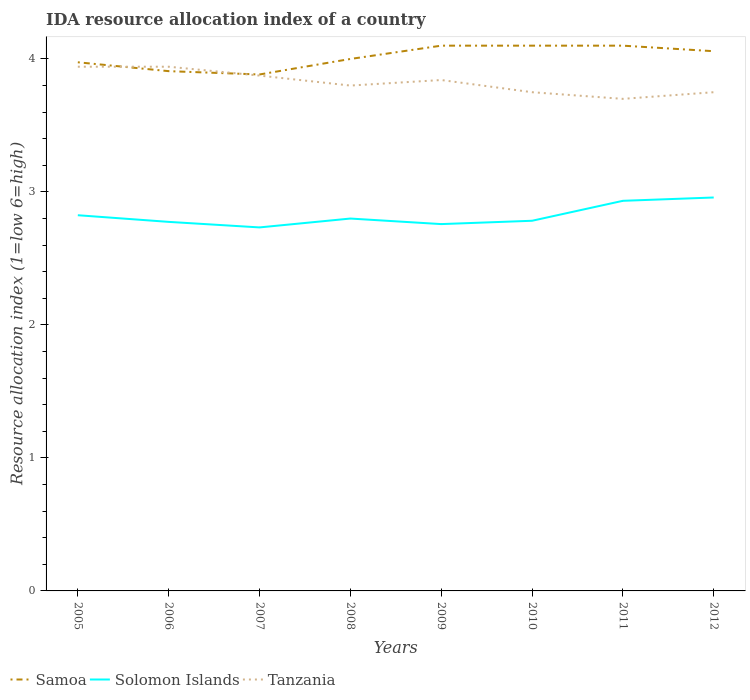How many different coloured lines are there?
Your response must be concise. 3. Does the line corresponding to Solomon Islands intersect with the line corresponding to Tanzania?
Provide a short and direct response. No. Across all years, what is the maximum IDA resource allocation index in Samoa?
Offer a terse response. 3.88. In which year was the IDA resource allocation index in Tanzania maximum?
Ensure brevity in your answer.  2011. What is the total IDA resource allocation index in Samoa in the graph?
Ensure brevity in your answer.  -0.12. What is the difference between the highest and the second highest IDA resource allocation index in Samoa?
Your answer should be very brief. 0.22. Does the graph contain any zero values?
Your response must be concise. No. Does the graph contain grids?
Provide a succinct answer. No. Where does the legend appear in the graph?
Keep it short and to the point. Bottom left. How many legend labels are there?
Keep it short and to the point. 3. How are the legend labels stacked?
Provide a succinct answer. Horizontal. What is the title of the graph?
Provide a short and direct response. IDA resource allocation index of a country. What is the label or title of the X-axis?
Give a very brief answer. Years. What is the label or title of the Y-axis?
Your answer should be compact. Resource allocation index (1=low 6=high). What is the Resource allocation index (1=low 6=high) in Samoa in 2005?
Your answer should be compact. 3.98. What is the Resource allocation index (1=low 6=high) in Solomon Islands in 2005?
Offer a terse response. 2.83. What is the Resource allocation index (1=low 6=high) of Tanzania in 2005?
Keep it short and to the point. 3.94. What is the Resource allocation index (1=low 6=high) of Samoa in 2006?
Keep it short and to the point. 3.91. What is the Resource allocation index (1=low 6=high) of Solomon Islands in 2006?
Provide a short and direct response. 2.77. What is the Resource allocation index (1=low 6=high) of Tanzania in 2006?
Your response must be concise. 3.94. What is the Resource allocation index (1=low 6=high) of Samoa in 2007?
Keep it short and to the point. 3.88. What is the Resource allocation index (1=low 6=high) in Solomon Islands in 2007?
Ensure brevity in your answer.  2.73. What is the Resource allocation index (1=low 6=high) in Tanzania in 2007?
Provide a short and direct response. 3.88. What is the Resource allocation index (1=low 6=high) of Samoa in 2008?
Keep it short and to the point. 4. What is the Resource allocation index (1=low 6=high) of Solomon Islands in 2008?
Provide a succinct answer. 2.8. What is the Resource allocation index (1=low 6=high) of Samoa in 2009?
Give a very brief answer. 4.1. What is the Resource allocation index (1=low 6=high) in Solomon Islands in 2009?
Your answer should be very brief. 2.76. What is the Resource allocation index (1=low 6=high) of Tanzania in 2009?
Your answer should be very brief. 3.84. What is the Resource allocation index (1=low 6=high) of Samoa in 2010?
Give a very brief answer. 4.1. What is the Resource allocation index (1=low 6=high) in Solomon Islands in 2010?
Your response must be concise. 2.78. What is the Resource allocation index (1=low 6=high) of Tanzania in 2010?
Offer a terse response. 3.75. What is the Resource allocation index (1=low 6=high) of Samoa in 2011?
Provide a short and direct response. 4.1. What is the Resource allocation index (1=low 6=high) of Solomon Islands in 2011?
Offer a terse response. 2.93. What is the Resource allocation index (1=low 6=high) of Tanzania in 2011?
Provide a short and direct response. 3.7. What is the Resource allocation index (1=low 6=high) in Samoa in 2012?
Make the answer very short. 4.06. What is the Resource allocation index (1=low 6=high) in Solomon Islands in 2012?
Ensure brevity in your answer.  2.96. What is the Resource allocation index (1=low 6=high) in Tanzania in 2012?
Offer a very short reply. 3.75. Across all years, what is the maximum Resource allocation index (1=low 6=high) in Samoa?
Offer a very short reply. 4.1. Across all years, what is the maximum Resource allocation index (1=low 6=high) of Solomon Islands?
Provide a succinct answer. 2.96. Across all years, what is the maximum Resource allocation index (1=low 6=high) of Tanzania?
Your answer should be compact. 3.94. Across all years, what is the minimum Resource allocation index (1=low 6=high) in Samoa?
Your response must be concise. 3.88. Across all years, what is the minimum Resource allocation index (1=low 6=high) of Solomon Islands?
Offer a very short reply. 2.73. What is the total Resource allocation index (1=low 6=high) of Samoa in the graph?
Ensure brevity in your answer.  32.12. What is the total Resource allocation index (1=low 6=high) in Solomon Islands in the graph?
Provide a succinct answer. 22.57. What is the total Resource allocation index (1=low 6=high) in Tanzania in the graph?
Your answer should be compact. 30.6. What is the difference between the Resource allocation index (1=low 6=high) of Samoa in 2005 and that in 2006?
Provide a short and direct response. 0.07. What is the difference between the Resource allocation index (1=low 6=high) of Samoa in 2005 and that in 2007?
Ensure brevity in your answer.  0.09. What is the difference between the Resource allocation index (1=low 6=high) in Solomon Islands in 2005 and that in 2007?
Offer a very short reply. 0.09. What is the difference between the Resource allocation index (1=low 6=high) in Tanzania in 2005 and that in 2007?
Provide a short and direct response. 0.07. What is the difference between the Resource allocation index (1=low 6=high) in Samoa in 2005 and that in 2008?
Give a very brief answer. -0.03. What is the difference between the Resource allocation index (1=low 6=high) in Solomon Islands in 2005 and that in 2008?
Your response must be concise. 0.03. What is the difference between the Resource allocation index (1=low 6=high) of Tanzania in 2005 and that in 2008?
Ensure brevity in your answer.  0.14. What is the difference between the Resource allocation index (1=low 6=high) of Samoa in 2005 and that in 2009?
Provide a succinct answer. -0.12. What is the difference between the Resource allocation index (1=low 6=high) of Solomon Islands in 2005 and that in 2009?
Offer a very short reply. 0.07. What is the difference between the Resource allocation index (1=low 6=high) in Samoa in 2005 and that in 2010?
Provide a succinct answer. -0.12. What is the difference between the Resource allocation index (1=low 6=high) of Solomon Islands in 2005 and that in 2010?
Make the answer very short. 0.04. What is the difference between the Resource allocation index (1=low 6=high) of Tanzania in 2005 and that in 2010?
Ensure brevity in your answer.  0.19. What is the difference between the Resource allocation index (1=low 6=high) of Samoa in 2005 and that in 2011?
Keep it short and to the point. -0.12. What is the difference between the Resource allocation index (1=low 6=high) in Solomon Islands in 2005 and that in 2011?
Provide a succinct answer. -0.11. What is the difference between the Resource allocation index (1=low 6=high) in Tanzania in 2005 and that in 2011?
Give a very brief answer. 0.24. What is the difference between the Resource allocation index (1=low 6=high) in Samoa in 2005 and that in 2012?
Offer a terse response. -0.08. What is the difference between the Resource allocation index (1=low 6=high) in Solomon Islands in 2005 and that in 2012?
Your answer should be very brief. -0.13. What is the difference between the Resource allocation index (1=low 6=high) of Tanzania in 2005 and that in 2012?
Your response must be concise. 0.19. What is the difference between the Resource allocation index (1=low 6=high) of Samoa in 2006 and that in 2007?
Ensure brevity in your answer.  0.03. What is the difference between the Resource allocation index (1=low 6=high) of Solomon Islands in 2006 and that in 2007?
Keep it short and to the point. 0.04. What is the difference between the Resource allocation index (1=low 6=high) in Tanzania in 2006 and that in 2007?
Provide a short and direct response. 0.07. What is the difference between the Resource allocation index (1=low 6=high) in Samoa in 2006 and that in 2008?
Give a very brief answer. -0.09. What is the difference between the Resource allocation index (1=low 6=high) in Solomon Islands in 2006 and that in 2008?
Your answer should be very brief. -0.03. What is the difference between the Resource allocation index (1=low 6=high) in Tanzania in 2006 and that in 2008?
Your answer should be compact. 0.14. What is the difference between the Resource allocation index (1=low 6=high) in Samoa in 2006 and that in 2009?
Your answer should be very brief. -0.19. What is the difference between the Resource allocation index (1=low 6=high) of Solomon Islands in 2006 and that in 2009?
Your response must be concise. 0.02. What is the difference between the Resource allocation index (1=low 6=high) of Tanzania in 2006 and that in 2009?
Offer a terse response. 0.1. What is the difference between the Resource allocation index (1=low 6=high) of Samoa in 2006 and that in 2010?
Offer a very short reply. -0.19. What is the difference between the Resource allocation index (1=low 6=high) of Solomon Islands in 2006 and that in 2010?
Ensure brevity in your answer.  -0.01. What is the difference between the Resource allocation index (1=low 6=high) in Tanzania in 2006 and that in 2010?
Offer a very short reply. 0.19. What is the difference between the Resource allocation index (1=low 6=high) in Samoa in 2006 and that in 2011?
Offer a terse response. -0.19. What is the difference between the Resource allocation index (1=low 6=high) in Solomon Islands in 2006 and that in 2011?
Offer a very short reply. -0.16. What is the difference between the Resource allocation index (1=low 6=high) of Tanzania in 2006 and that in 2011?
Keep it short and to the point. 0.24. What is the difference between the Resource allocation index (1=low 6=high) in Samoa in 2006 and that in 2012?
Give a very brief answer. -0.15. What is the difference between the Resource allocation index (1=low 6=high) in Solomon Islands in 2006 and that in 2012?
Make the answer very short. -0.18. What is the difference between the Resource allocation index (1=low 6=high) in Tanzania in 2006 and that in 2012?
Keep it short and to the point. 0.19. What is the difference between the Resource allocation index (1=low 6=high) in Samoa in 2007 and that in 2008?
Make the answer very short. -0.12. What is the difference between the Resource allocation index (1=low 6=high) in Solomon Islands in 2007 and that in 2008?
Make the answer very short. -0.07. What is the difference between the Resource allocation index (1=low 6=high) in Tanzania in 2007 and that in 2008?
Your response must be concise. 0.07. What is the difference between the Resource allocation index (1=low 6=high) of Samoa in 2007 and that in 2009?
Offer a very short reply. -0.22. What is the difference between the Resource allocation index (1=low 6=high) of Solomon Islands in 2007 and that in 2009?
Keep it short and to the point. -0.03. What is the difference between the Resource allocation index (1=low 6=high) in Samoa in 2007 and that in 2010?
Your response must be concise. -0.22. What is the difference between the Resource allocation index (1=low 6=high) in Solomon Islands in 2007 and that in 2010?
Offer a terse response. -0.05. What is the difference between the Resource allocation index (1=low 6=high) in Samoa in 2007 and that in 2011?
Keep it short and to the point. -0.22. What is the difference between the Resource allocation index (1=low 6=high) of Tanzania in 2007 and that in 2011?
Give a very brief answer. 0.17. What is the difference between the Resource allocation index (1=low 6=high) of Samoa in 2007 and that in 2012?
Provide a short and direct response. -0.17. What is the difference between the Resource allocation index (1=low 6=high) in Solomon Islands in 2007 and that in 2012?
Give a very brief answer. -0.23. What is the difference between the Resource allocation index (1=low 6=high) in Solomon Islands in 2008 and that in 2009?
Provide a short and direct response. 0.04. What is the difference between the Resource allocation index (1=low 6=high) of Tanzania in 2008 and that in 2009?
Offer a very short reply. -0.04. What is the difference between the Resource allocation index (1=low 6=high) of Solomon Islands in 2008 and that in 2010?
Provide a succinct answer. 0.02. What is the difference between the Resource allocation index (1=low 6=high) in Tanzania in 2008 and that in 2010?
Offer a terse response. 0.05. What is the difference between the Resource allocation index (1=low 6=high) in Solomon Islands in 2008 and that in 2011?
Your response must be concise. -0.13. What is the difference between the Resource allocation index (1=low 6=high) of Samoa in 2008 and that in 2012?
Offer a terse response. -0.06. What is the difference between the Resource allocation index (1=low 6=high) in Solomon Islands in 2008 and that in 2012?
Offer a very short reply. -0.16. What is the difference between the Resource allocation index (1=low 6=high) in Tanzania in 2008 and that in 2012?
Provide a short and direct response. 0.05. What is the difference between the Resource allocation index (1=low 6=high) of Samoa in 2009 and that in 2010?
Ensure brevity in your answer.  0. What is the difference between the Resource allocation index (1=low 6=high) of Solomon Islands in 2009 and that in 2010?
Ensure brevity in your answer.  -0.03. What is the difference between the Resource allocation index (1=low 6=high) of Tanzania in 2009 and that in 2010?
Ensure brevity in your answer.  0.09. What is the difference between the Resource allocation index (1=low 6=high) in Solomon Islands in 2009 and that in 2011?
Offer a terse response. -0.17. What is the difference between the Resource allocation index (1=low 6=high) of Tanzania in 2009 and that in 2011?
Keep it short and to the point. 0.14. What is the difference between the Resource allocation index (1=low 6=high) of Samoa in 2009 and that in 2012?
Provide a succinct answer. 0.04. What is the difference between the Resource allocation index (1=low 6=high) in Tanzania in 2009 and that in 2012?
Keep it short and to the point. 0.09. What is the difference between the Resource allocation index (1=low 6=high) in Samoa in 2010 and that in 2011?
Provide a succinct answer. 0. What is the difference between the Resource allocation index (1=low 6=high) of Solomon Islands in 2010 and that in 2011?
Offer a terse response. -0.15. What is the difference between the Resource allocation index (1=low 6=high) of Tanzania in 2010 and that in 2011?
Your answer should be very brief. 0.05. What is the difference between the Resource allocation index (1=low 6=high) in Samoa in 2010 and that in 2012?
Keep it short and to the point. 0.04. What is the difference between the Resource allocation index (1=low 6=high) in Solomon Islands in 2010 and that in 2012?
Offer a very short reply. -0.17. What is the difference between the Resource allocation index (1=low 6=high) in Tanzania in 2010 and that in 2012?
Offer a terse response. 0. What is the difference between the Resource allocation index (1=low 6=high) of Samoa in 2011 and that in 2012?
Your answer should be compact. 0.04. What is the difference between the Resource allocation index (1=low 6=high) in Solomon Islands in 2011 and that in 2012?
Your answer should be very brief. -0.03. What is the difference between the Resource allocation index (1=low 6=high) in Tanzania in 2011 and that in 2012?
Offer a terse response. -0.05. What is the difference between the Resource allocation index (1=low 6=high) in Solomon Islands in 2005 and the Resource allocation index (1=low 6=high) in Tanzania in 2006?
Ensure brevity in your answer.  -1.12. What is the difference between the Resource allocation index (1=low 6=high) of Samoa in 2005 and the Resource allocation index (1=low 6=high) of Solomon Islands in 2007?
Your answer should be very brief. 1.24. What is the difference between the Resource allocation index (1=low 6=high) in Samoa in 2005 and the Resource allocation index (1=low 6=high) in Tanzania in 2007?
Give a very brief answer. 0.1. What is the difference between the Resource allocation index (1=low 6=high) of Solomon Islands in 2005 and the Resource allocation index (1=low 6=high) of Tanzania in 2007?
Offer a very short reply. -1.05. What is the difference between the Resource allocation index (1=low 6=high) of Samoa in 2005 and the Resource allocation index (1=low 6=high) of Solomon Islands in 2008?
Offer a terse response. 1.18. What is the difference between the Resource allocation index (1=low 6=high) in Samoa in 2005 and the Resource allocation index (1=low 6=high) in Tanzania in 2008?
Make the answer very short. 0.17. What is the difference between the Resource allocation index (1=low 6=high) of Solomon Islands in 2005 and the Resource allocation index (1=low 6=high) of Tanzania in 2008?
Provide a succinct answer. -0.97. What is the difference between the Resource allocation index (1=low 6=high) in Samoa in 2005 and the Resource allocation index (1=low 6=high) in Solomon Islands in 2009?
Keep it short and to the point. 1.22. What is the difference between the Resource allocation index (1=low 6=high) in Samoa in 2005 and the Resource allocation index (1=low 6=high) in Tanzania in 2009?
Your response must be concise. 0.13. What is the difference between the Resource allocation index (1=low 6=high) in Solomon Islands in 2005 and the Resource allocation index (1=low 6=high) in Tanzania in 2009?
Offer a very short reply. -1.02. What is the difference between the Resource allocation index (1=low 6=high) in Samoa in 2005 and the Resource allocation index (1=low 6=high) in Solomon Islands in 2010?
Your answer should be compact. 1.19. What is the difference between the Resource allocation index (1=low 6=high) in Samoa in 2005 and the Resource allocation index (1=low 6=high) in Tanzania in 2010?
Ensure brevity in your answer.  0.23. What is the difference between the Resource allocation index (1=low 6=high) of Solomon Islands in 2005 and the Resource allocation index (1=low 6=high) of Tanzania in 2010?
Offer a very short reply. -0.93. What is the difference between the Resource allocation index (1=low 6=high) of Samoa in 2005 and the Resource allocation index (1=low 6=high) of Solomon Islands in 2011?
Make the answer very short. 1.04. What is the difference between the Resource allocation index (1=low 6=high) in Samoa in 2005 and the Resource allocation index (1=low 6=high) in Tanzania in 2011?
Offer a terse response. 0.28. What is the difference between the Resource allocation index (1=low 6=high) of Solomon Islands in 2005 and the Resource allocation index (1=low 6=high) of Tanzania in 2011?
Make the answer very short. -0.88. What is the difference between the Resource allocation index (1=low 6=high) of Samoa in 2005 and the Resource allocation index (1=low 6=high) of Solomon Islands in 2012?
Ensure brevity in your answer.  1.02. What is the difference between the Resource allocation index (1=low 6=high) of Samoa in 2005 and the Resource allocation index (1=low 6=high) of Tanzania in 2012?
Provide a succinct answer. 0.23. What is the difference between the Resource allocation index (1=low 6=high) in Solomon Islands in 2005 and the Resource allocation index (1=low 6=high) in Tanzania in 2012?
Your answer should be very brief. -0.93. What is the difference between the Resource allocation index (1=low 6=high) of Samoa in 2006 and the Resource allocation index (1=low 6=high) of Solomon Islands in 2007?
Make the answer very short. 1.18. What is the difference between the Resource allocation index (1=low 6=high) of Solomon Islands in 2006 and the Resource allocation index (1=low 6=high) of Tanzania in 2007?
Your answer should be compact. -1.1. What is the difference between the Resource allocation index (1=low 6=high) of Samoa in 2006 and the Resource allocation index (1=low 6=high) of Solomon Islands in 2008?
Offer a terse response. 1.11. What is the difference between the Resource allocation index (1=low 6=high) of Samoa in 2006 and the Resource allocation index (1=low 6=high) of Tanzania in 2008?
Your response must be concise. 0.11. What is the difference between the Resource allocation index (1=low 6=high) in Solomon Islands in 2006 and the Resource allocation index (1=low 6=high) in Tanzania in 2008?
Give a very brief answer. -1.02. What is the difference between the Resource allocation index (1=low 6=high) of Samoa in 2006 and the Resource allocation index (1=low 6=high) of Solomon Islands in 2009?
Ensure brevity in your answer.  1.15. What is the difference between the Resource allocation index (1=low 6=high) of Samoa in 2006 and the Resource allocation index (1=low 6=high) of Tanzania in 2009?
Provide a short and direct response. 0.07. What is the difference between the Resource allocation index (1=low 6=high) of Solomon Islands in 2006 and the Resource allocation index (1=low 6=high) of Tanzania in 2009?
Your response must be concise. -1.07. What is the difference between the Resource allocation index (1=low 6=high) in Samoa in 2006 and the Resource allocation index (1=low 6=high) in Tanzania in 2010?
Keep it short and to the point. 0.16. What is the difference between the Resource allocation index (1=low 6=high) in Solomon Islands in 2006 and the Resource allocation index (1=low 6=high) in Tanzania in 2010?
Offer a terse response. -0.97. What is the difference between the Resource allocation index (1=low 6=high) of Samoa in 2006 and the Resource allocation index (1=low 6=high) of Tanzania in 2011?
Give a very brief answer. 0.21. What is the difference between the Resource allocation index (1=low 6=high) of Solomon Islands in 2006 and the Resource allocation index (1=low 6=high) of Tanzania in 2011?
Provide a succinct answer. -0.93. What is the difference between the Resource allocation index (1=low 6=high) in Samoa in 2006 and the Resource allocation index (1=low 6=high) in Solomon Islands in 2012?
Provide a succinct answer. 0.95. What is the difference between the Resource allocation index (1=low 6=high) of Samoa in 2006 and the Resource allocation index (1=low 6=high) of Tanzania in 2012?
Provide a short and direct response. 0.16. What is the difference between the Resource allocation index (1=low 6=high) in Solomon Islands in 2006 and the Resource allocation index (1=low 6=high) in Tanzania in 2012?
Ensure brevity in your answer.  -0.97. What is the difference between the Resource allocation index (1=low 6=high) of Samoa in 2007 and the Resource allocation index (1=low 6=high) of Tanzania in 2008?
Make the answer very short. 0.08. What is the difference between the Resource allocation index (1=low 6=high) in Solomon Islands in 2007 and the Resource allocation index (1=low 6=high) in Tanzania in 2008?
Provide a short and direct response. -1.07. What is the difference between the Resource allocation index (1=low 6=high) in Samoa in 2007 and the Resource allocation index (1=low 6=high) in Tanzania in 2009?
Keep it short and to the point. 0.04. What is the difference between the Resource allocation index (1=low 6=high) in Solomon Islands in 2007 and the Resource allocation index (1=low 6=high) in Tanzania in 2009?
Your answer should be very brief. -1.11. What is the difference between the Resource allocation index (1=low 6=high) of Samoa in 2007 and the Resource allocation index (1=low 6=high) of Solomon Islands in 2010?
Provide a short and direct response. 1.1. What is the difference between the Resource allocation index (1=low 6=high) of Samoa in 2007 and the Resource allocation index (1=low 6=high) of Tanzania in 2010?
Provide a short and direct response. 0.13. What is the difference between the Resource allocation index (1=low 6=high) in Solomon Islands in 2007 and the Resource allocation index (1=low 6=high) in Tanzania in 2010?
Provide a succinct answer. -1.02. What is the difference between the Resource allocation index (1=low 6=high) of Samoa in 2007 and the Resource allocation index (1=low 6=high) of Solomon Islands in 2011?
Offer a very short reply. 0.95. What is the difference between the Resource allocation index (1=low 6=high) of Samoa in 2007 and the Resource allocation index (1=low 6=high) of Tanzania in 2011?
Ensure brevity in your answer.  0.18. What is the difference between the Resource allocation index (1=low 6=high) in Solomon Islands in 2007 and the Resource allocation index (1=low 6=high) in Tanzania in 2011?
Ensure brevity in your answer.  -0.97. What is the difference between the Resource allocation index (1=low 6=high) of Samoa in 2007 and the Resource allocation index (1=low 6=high) of Solomon Islands in 2012?
Give a very brief answer. 0.93. What is the difference between the Resource allocation index (1=low 6=high) in Samoa in 2007 and the Resource allocation index (1=low 6=high) in Tanzania in 2012?
Your answer should be compact. 0.13. What is the difference between the Resource allocation index (1=low 6=high) in Solomon Islands in 2007 and the Resource allocation index (1=low 6=high) in Tanzania in 2012?
Ensure brevity in your answer.  -1.02. What is the difference between the Resource allocation index (1=low 6=high) of Samoa in 2008 and the Resource allocation index (1=low 6=high) of Solomon Islands in 2009?
Offer a terse response. 1.24. What is the difference between the Resource allocation index (1=low 6=high) of Samoa in 2008 and the Resource allocation index (1=low 6=high) of Tanzania in 2009?
Your answer should be compact. 0.16. What is the difference between the Resource allocation index (1=low 6=high) in Solomon Islands in 2008 and the Resource allocation index (1=low 6=high) in Tanzania in 2009?
Your answer should be compact. -1.04. What is the difference between the Resource allocation index (1=low 6=high) in Samoa in 2008 and the Resource allocation index (1=low 6=high) in Solomon Islands in 2010?
Your answer should be compact. 1.22. What is the difference between the Resource allocation index (1=low 6=high) in Samoa in 2008 and the Resource allocation index (1=low 6=high) in Tanzania in 2010?
Your answer should be very brief. 0.25. What is the difference between the Resource allocation index (1=low 6=high) of Solomon Islands in 2008 and the Resource allocation index (1=low 6=high) of Tanzania in 2010?
Ensure brevity in your answer.  -0.95. What is the difference between the Resource allocation index (1=low 6=high) of Samoa in 2008 and the Resource allocation index (1=low 6=high) of Solomon Islands in 2011?
Your answer should be very brief. 1.07. What is the difference between the Resource allocation index (1=low 6=high) in Samoa in 2008 and the Resource allocation index (1=low 6=high) in Tanzania in 2011?
Make the answer very short. 0.3. What is the difference between the Resource allocation index (1=low 6=high) in Solomon Islands in 2008 and the Resource allocation index (1=low 6=high) in Tanzania in 2011?
Offer a very short reply. -0.9. What is the difference between the Resource allocation index (1=low 6=high) of Samoa in 2008 and the Resource allocation index (1=low 6=high) of Solomon Islands in 2012?
Provide a short and direct response. 1.04. What is the difference between the Resource allocation index (1=low 6=high) of Samoa in 2008 and the Resource allocation index (1=low 6=high) of Tanzania in 2012?
Your response must be concise. 0.25. What is the difference between the Resource allocation index (1=low 6=high) of Solomon Islands in 2008 and the Resource allocation index (1=low 6=high) of Tanzania in 2012?
Provide a succinct answer. -0.95. What is the difference between the Resource allocation index (1=low 6=high) in Samoa in 2009 and the Resource allocation index (1=low 6=high) in Solomon Islands in 2010?
Provide a short and direct response. 1.32. What is the difference between the Resource allocation index (1=low 6=high) of Samoa in 2009 and the Resource allocation index (1=low 6=high) of Tanzania in 2010?
Offer a very short reply. 0.35. What is the difference between the Resource allocation index (1=low 6=high) in Solomon Islands in 2009 and the Resource allocation index (1=low 6=high) in Tanzania in 2010?
Make the answer very short. -0.99. What is the difference between the Resource allocation index (1=low 6=high) of Solomon Islands in 2009 and the Resource allocation index (1=low 6=high) of Tanzania in 2011?
Make the answer very short. -0.94. What is the difference between the Resource allocation index (1=low 6=high) in Samoa in 2009 and the Resource allocation index (1=low 6=high) in Solomon Islands in 2012?
Provide a succinct answer. 1.14. What is the difference between the Resource allocation index (1=low 6=high) of Solomon Islands in 2009 and the Resource allocation index (1=low 6=high) of Tanzania in 2012?
Keep it short and to the point. -0.99. What is the difference between the Resource allocation index (1=low 6=high) in Samoa in 2010 and the Resource allocation index (1=low 6=high) in Solomon Islands in 2011?
Keep it short and to the point. 1.17. What is the difference between the Resource allocation index (1=low 6=high) in Solomon Islands in 2010 and the Resource allocation index (1=low 6=high) in Tanzania in 2011?
Make the answer very short. -0.92. What is the difference between the Resource allocation index (1=low 6=high) in Samoa in 2010 and the Resource allocation index (1=low 6=high) in Solomon Islands in 2012?
Give a very brief answer. 1.14. What is the difference between the Resource allocation index (1=low 6=high) of Solomon Islands in 2010 and the Resource allocation index (1=low 6=high) of Tanzania in 2012?
Give a very brief answer. -0.97. What is the difference between the Resource allocation index (1=low 6=high) in Samoa in 2011 and the Resource allocation index (1=low 6=high) in Solomon Islands in 2012?
Your answer should be compact. 1.14. What is the difference between the Resource allocation index (1=low 6=high) in Samoa in 2011 and the Resource allocation index (1=low 6=high) in Tanzania in 2012?
Keep it short and to the point. 0.35. What is the difference between the Resource allocation index (1=low 6=high) in Solomon Islands in 2011 and the Resource allocation index (1=low 6=high) in Tanzania in 2012?
Offer a very short reply. -0.82. What is the average Resource allocation index (1=low 6=high) of Samoa per year?
Offer a terse response. 4.02. What is the average Resource allocation index (1=low 6=high) in Solomon Islands per year?
Ensure brevity in your answer.  2.82. What is the average Resource allocation index (1=low 6=high) in Tanzania per year?
Offer a terse response. 3.83. In the year 2005, what is the difference between the Resource allocation index (1=low 6=high) in Samoa and Resource allocation index (1=low 6=high) in Solomon Islands?
Offer a terse response. 1.15. In the year 2005, what is the difference between the Resource allocation index (1=low 6=high) in Samoa and Resource allocation index (1=low 6=high) in Tanzania?
Offer a very short reply. 0.03. In the year 2005, what is the difference between the Resource allocation index (1=low 6=high) in Solomon Islands and Resource allocation index (1=low 6=high) in Tanzania?
Keep it short and to the point. -1.12. In the year 2006, what is the difference between the Resource allocation index (1=low 6=high) of Samoa and Resource allocation index (1=low 6=high) of Solomon Islands?
Your response must be concise. 1.13. In the year 2006, what is the difference between the Resource allocation index (1=low 6=high) in Samoa and Resource allocation index (1=low 6=high) in Tanzania?
Keep it short and to the point. -0.03. In the year 2006, what is the difference between the Resource allocation index (1=low 6=high) in Solomon Islands and Resource allocation index (1=low 6=high) in Tanzania?
Keep it short and to the point. -1.17. In the year 2007, what is the difference between the Resource allocation index (1=low 6=high) of Samoa and Resource allocation index (1=low 6=high) of Solomon Islands?
Provide a succinct answer. 1.15. In the year 2007, what is the difference between the Resource allocation index (1=low 6=high) of Samoa and Resource allocation index (1=low 6=high) of Tanzania?
Make the answer very short. 0.01. In the year 2007, what is the difference between the Resource allocation index (1=low 6=high) in Solomon Islands and Resource allocation index (1=low 6=high) in Tanzania?
Your answer should be compact. -1.14. In the year 2008, what is the difference between the Resource allocation index (1=low 6=high) of Samoa and Resource allocation index (1=low 6=high) of Solomon Islands?
Give a very brief answer. 1.2. In the year 2009, what is the difference between the Resource allocation index (1=low 6=high) in Samoa and Resource allocation index (1=low 6=high) in Solomon Islands?
Ensure brevity in your answer.  1.34. In the year 2009, what is the difference between the Resource allocation index (1=low 6=high) in Samoa and Resource allocation index (1=low 6=high) in Tanzania?
Offer a terse response. 0.26. In the year 2009, what is the difference between the Resource allocation index (1=low 6=high) in Solomon Islands and Resource allocation index (1=low 6=high) in Tanzania?
Offer a terse response. -1.08. In the year 2010, what is the difference between the Resource allocation index (1=low 6=high) of Samoa and Resource allocation index (1=low 6=high) of Solomon Islands?
Ensure brevity in your answer.  1.32. In the year 2010, what is the difference between the Resource allocation index (1=low 6=high) in Solomon Islands and Resource allocation index (1=low 6=high) in Tanzania?
Ensure brevity in your answer.  -0.97. In the year 2011, what is the difference between the Resource allocation index (1=low 6=high) of Samoa and Resource allocation index (1=low 6=high) of Solomon Islands?
Ensure brevity in your answer.  1.17. In the year 2011, what is the difference between the Resource allocation index (1=low 6=high) of Solomon Islands and Resource allocation index (1=low 6=high) of Tanzania?
Your answer should be very brief. -0.77. In the year 2012, what is the difference between the Resource allocation index (1=low 6=high) of Samoa and Resource allocation index (1=low 6=high) of Tanzania?
Keep it short and to the point. 0.31. In the year 2012, what is the difference between the Resource allocation index (1=low 6=high) in Solomon Islands and Resource allocation index (1=low 6=high) in Tanzania?
Your answer should be very brief. -0.79. What is the ratio of the Resource allocation index (1=low 6=high) in Samoa in 2005 to that in 2006?
Your answer should be very brief. 1.02. What is the ratio of the Resource allocation index (1=low 6=high) of Tanzania in 2005 to that in 2006?
Give a very brief answer. 1. What is the ratio of the Resource allocation index (1=low 6=high) of Samoa in 2005 to that in 2007?
Keep it short and to the point. 1.02. What is the ratio of the Resource allocation index (1=low 6=high) in Solomon Islands in 2005 to that in 2007?
Your answer should be very brief. 1.03. What is the ratio of the Resource allocation index (1=low 6=high) of Tanzania in 2005 to that in 2007?
Offer a very short reply. 1.02. What is the ratio of the Resource allocation index (1=low 6=high) of Samoa in 2005 to that in 2008?
Give a very brief answer. 0.99. What is the ratio of the Resource allocation index (1=low 6=high) in Solomon Islands in 2005 to that in 2008?
Your response must be concise. 1.01. What is the ratio of the Resource allocation index (1=low 6=high) of Tanzania in 2005 to that in 2008?
Your answer should be compact. 1.04. What is the ratio of the Resource allocation index (1=low 6=high) in Samoa in 2005 to that in 2009?
Offer a terse response. 0.97. What is the ratio of the Resource allocation index (1=low 6=high) in Solomon Islands in 2005 to that in 2009?
Make the answer very short. 1.02. What is the ratio of the Resource allocation index (1=low 6=high) in Samoa in 2005 to that in 2010?
Your response must be concise. 0.97. What is the ratio of the Resource allocation index (1=low 6=high) of Solomon Islands in 2005 to that in 2010?
Make the answer very short. 1.01. What is the ratio of the Resource allocation index (1=low 6=high) of Tanzania in 2005 to that in 2010?
Provide a succinct answer. 1.05. What is the ratio of the Resource allocation index (1=low 6=high) in Samoa in 2005 to that in 2011?
Provide a succinct answer. 0.97. What is the ratio of the Resource allocation index (1=low 6=high) in Solomon Islands in 2005 to that in 2011?
Offer a terse response. 0.96. What is the ratio of the Resource allocation index (1=low 6=high) in Tanzania in 2005 to that in 2011?
Provide a short and direct response. 1.07. What is the ratio of the Resource allocation index (1=low 6=high) of Samoa in 2005 to that in 2012?
Offer a terse response. 0.98. What is the ratio of the Resource allocation index (1=low 6=high) of Solomon Islands in 2005 to that in 2012?
Offer a very short reply. 0.95. What is the ratio of the Resource allocation index (1=low 6=high) of Tanzania in 2005 to that in 2012?
Your response must be concise. 1.05. What is the ratio of the Resource allocation index (1=low 6=high) in Samoa in 2006 to that in 2007?
Offer a terse response. 1.01. What is the ratio of the Resource allocation index (1=low 6=high) in Solomon Islands in 2006 to that in 2007?
Your answer should be compact. 1.02. What is the ratio of the Resource allocation index (1=low 6=high) in Tanzania in 2006 to that in 2007?
Your answer should be very brief. 1.02. What is the ratio of the Resource allocation index (1=low 6=high) of Samoa in 2006 to that in 2008?
Your answer should be compact. 0.98. What is the ratio of the Resource allocation index (1=low 6=high) of Solomon Islands in 2006 to that in 2008?
Keep it short and to the point. 0.99. What is the ratio of the Resource allocation index (1=low 6=high) in Tanzania in 2006 to that in 2008?
Offer a terse response. 1.04. What is the ratio of the Resource allocation index (1=low 6=high) in Samoa in 2006 to that in 2009?
Provide a short and direct response. 0.95. What is the ratio of the Resource allocation index (1=low 6=high) in Samoa in 2006 to that in 2010?
Ensure brevity in your answer.  0.95. What is the ratio of the Resource allocation index (1=low 6=high) of Solomon Islands in 2006 to that in 2010?
Offer a very short reply. 1. What is the ratio of the Resource allocation index (1=low 6=high) of Tanzania in 2006 to that in 2010?
Give a very brief answer. 1.05. What is the ratio of the Resource allocation index (1=low 6=high) in Samoa in 2006 to that in 2011?
Ensure brevity in your answer.  0.95. What is the ratio of the Resource allocation index (1=low 6=high) of Solomon Islands in 2006 to that in 2011?
Keep it short and to the point. 0.95. What is the ratio of the Resource allocation index (1=low 6=high) in Tanzania in 2006 to that in 2011?
Your answer should be compact. 1.07. What is the ratio of the Resource allocation index (1=low 6=high) of Solomon Islands in 2006 to that in 2012?
Provide a short and direct response. 0.94. What is the ratio of the Resource allocation index (1=low 6=high) of Tanzania in 2006 to that in 2012?
Make the answer very short. 1.05. What is the ratio of the Resource allocation index (1=low 6=high) of Samoa in 2007 to that in 2008?
Provide a short and direct response. 0.97. What is the ratio of the Resource allocation index (1=low 6=high) of Solomon Islands in 2007 to that in 2008?
Offer a terse response. 0.98. What is the ratio of the Resource allocation index (1=low 6=high) in Tanzania in 2007 to that in 2008?
Provide a succinct answer. 1.02. What is the ratio of the Resource allocation index (1=low 6=high) of Samoa in 2007 to that in 2009?
Keep it short and to the point. 0.95. What is the ratio of the Resource allocation index (1=low 6=high) of Solomon Islands in 2007 to that in 2009?
Make the answer very short. 0.99. What is the ratio of the Resource allocation index (1=low 6=high) of Tanzania in 2007 to that in 2009?
Your answer should be compact. 1.01. What is the ratio of the Resource allocation index (1=low 6=high) in Samoa in 2007 to that in 2010?
Keep it short and to the point. 0.95. What is the ratio of the Resource allocation index (1=low 6=high) of Samoa in 2007 to that in 2011?
Offer a very short reply. 0.95. What is the ratio of the Resource allocation index (1=low 6=high) of Solomon Islands in 2007 to that in 2011?
Keep it short and to the point. 0.93. What is the ratio of the Resource allocation index (1=low 6=high) in Tanzania in 2007 to that in 2011?
Offer a very short reply. 1.05. What is the ratio of the Resource allocation index (1=low 6=high) in Samoa in 2007 to that in 2012?
Keep it short and to the point. 0.96. What is the ratio of the Resource allocation index (1=low 6=high) of Solomon Islands in 2007 to that in 2012?
Your response must be concise. 0.92. What is the ratio of the Resource allocation index (1=low 6=high) of Tanzania in 2007 to that in 2012?
Your answer should be very brief. 1.03. What is the ratio of the Resource allocation index (1=low 6=high) of Samoa in 2008 to that in 2009?
Ensure brevity in your answer.  0.98. What is the ratio of the Resource allocation index (1=low 6=high) of Solomon Islands in 2008 to that in 2009?
Offer a terse response. 1.02. What is the ratio of the Resource allocation index (1=low 6=high) in Tanzania in 2008 to that in 2009?
Give a very brief answer. 0.99. What is the ratio of the Resource allocation index (1=low 6=high) of Samoa in 2008 to that in 2010?
Provide a succinct answer. 0.98. What is the ratio of the Resource allocation index (1=low 6=high) in Tanzania in 2008 to that in 2010?
Offer a terse response. 1.01. What is the ratio of the Resource allocation index (1=low 6=high) in Samoa in 2008 to that in 2011?
Offer a very short reply. 0.98. What is the ratio of the Resource allocation index (1=low 6=high) in Solomon Islands in 2008 to that in 2011?
Your answer should be very brief. 0.95. What is the ratio of the Resource allocation index (1=low 6=high) of Tanzania in 2008 to that in 2011?
Offer a very short reply. 1.03. What is the ratio of the Resource allocation index (1=low 6=high) in Samoa in 2008 to that in 2012?
Offer a very short reply. 0.99. What is the ratio of the Resource allocation index (1=low 6=high) of Solomon Islands in 2008 to that in 2012?
Ensure brevity in your answer.  0.95. What is the ratio of the Resource allocation index (1=low 6=high) in Tanzania in 2008 to that in 2012?
Keep it short and to the point. 1.01. What is the ratio of the Resource allocation index (1=low 6=high) of Samoa in 2009 to that in 2010?
Your response must be concise. 1. What is the ratio of the Resource allocation index (1=low 6=high) in Tanzania in 2009 to that in 2010?
Your response must be concise. 1.02. What is the ratio of the Resource allocation index (1=low 6=high) of Solomon Islands in 2009 to that in 2011?
Offer a very short reply. 0.94. What is the ratio of the Resource allocation index (1=low 6=high) in Tanzania in 2009 to that in 2011?
Offer a terse response. 1.04. What is the ratio of the Resource allocation index (1=low 6=high) in Samoa in 2009 to that in 2012?
Your answer should be compact. 1.01. What is the ratio of the Resource allocation index (1=low 6=high) of Solomon Islands in 2009 to that in 2012?
Provide a short and direct response. 0.93. What is the ratio of the Resource allocation index (1=low 6=high) in Tanzania in 2009 to that in 2012?
Provide a succinct answer. 1.02. What is the ratio of the Resource allocation index (1=low 6=high) in Samoa in 2010 to that in 2011?
Your answer should be compact. 1. What is the ratio of the Resource allocation index (1=low 6=high) in Solomon Islands in 2010 to that in 2011?
Provide a short and direct response. 0.95. What is the ratio of the Resource allocation index (1=low 6=high) of Tanzania in 2010 to that in 2011?
Offer a very short reply. 1.01. What is the ratio of the Resource allocation index (1=low 6=high) in Samoa in 2010 to that in 2012?
Your answer should be very brief. 1.01. What is the ratio of the Resource allocation index (1=low 6=high) in Solomon Islands in 2010 to that in 2012?
Your response must be concise. 0.94. What is the ratio of the Resource allocation index (1=low 6=high) of Samoa in 2011 to that in 2012?
Make the answer very short. 1.01. What is the ratio of the Resource allocation index (1=low 6=high) of Tanzania in 2011 to that in 2012?
Keep it short and to the point. 0.99. What is the difference between the highest and the second highest Resource allocation index (1=low 6=high) of Solomon Islands?
Keep it short and to the point. 0.03. What is the difference between the highest and the lowest Resource allocation index (1=low 6=high) in Samoa?
Give a very brief answer. 0.22. What is the difference between the highest and the lowest Resource allocation index (1=low 6=high) of Solomon Islands?
Keep it short and to the point. 0.23. What is the difference between the highest and the lowest Resource allocation index (1=low 6=high) of Tanzania?
Your answer should be very brief. 0.24. 